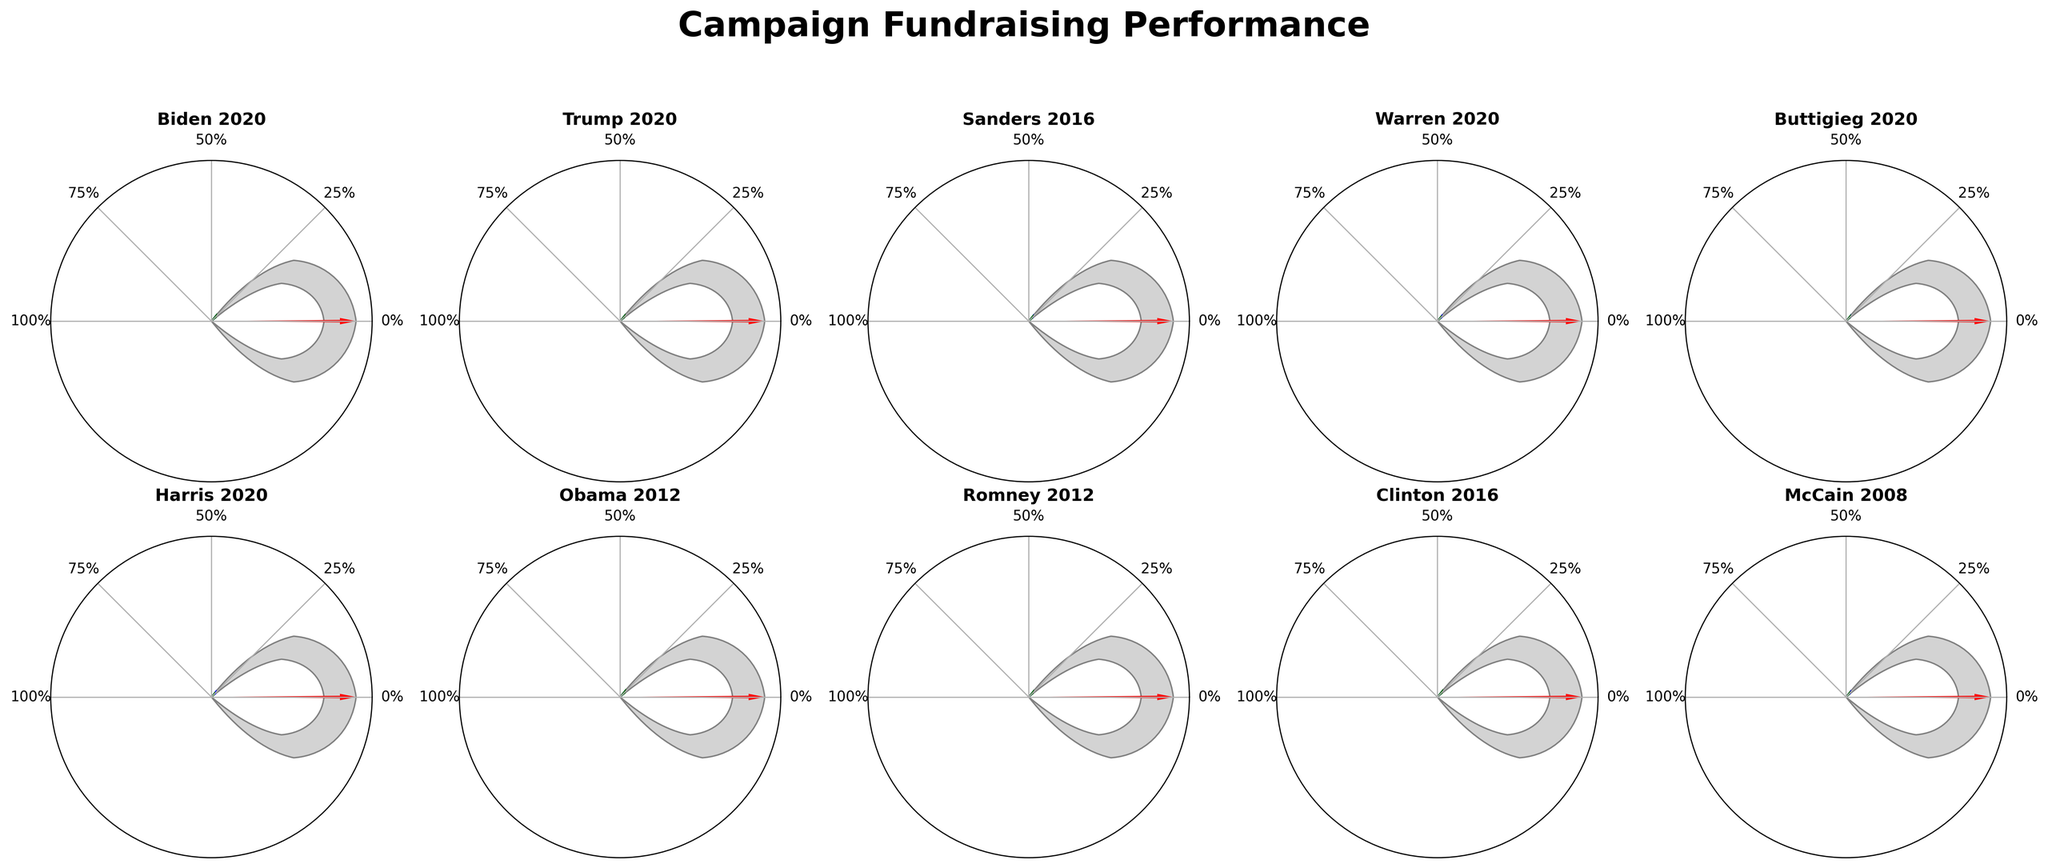How many campaigns surpassed their fundraising goal? From the rendering of the Gauge Charts, we observe the red needle as well as the green wedge. The needle indicates the actual amount raised, and when it exceeds the green wedge, this signifies that the goal was surpassed. The campaigns that surpassed their goals are Biden 2020, Obama 2012, and Clinton 2016.
Answer: 3 Which campaign had the largest difference between the raised amount and the goal? By looking at the gauge charts, we see that Obama 2012’s gauge extends furthest into the right, showing it surpassed its goal by 3%. This is the largest difference among all campaigns shown.
Answer: Obama 2012 Are there any campaigns that did not meet the industry benchmark? The industry benchmark is marked by a light blue wedge. Any campaign whose needle falls short of this wedge is below the industry benchmark. Analyzing the charts, Sanders 2016, Warren 2020, Buttigieg 2020, Harris 2020, and McCain 2008 did not meet the industry benchmark.
Answer: 5 campaigns What percentage of their goal did Trump 2020 raise? Referring to the needle in the Trump 2020 gauge chart, we see that it points to 92%.
Answer: 92% Which campaign raised the least amount relative to its goal? Analyzing the gauge charts, the Harris 2020 campaign shows the lowest amount, with the needle stopping at 57%.
Answer: Harris 2020 How many campaigns met the industry benchmark but did not surpass their goals? Campaigns meeting the benchmark but not surpassing their goal will have needles touching or surpassing the blue wedge but not extending beyond the 180-degree marker. Trump 2020, Sanders 2016, Buttigieg 2020, and Romney 2012 meet this condition.
Answer: 4 campaigns Was the raised amount from Clinton 2016 closer to the goal or the industry benchmark? The Clinton 2016 gauge chart shows a needle pointing just below the 100% mark, which is much closer to the goal (98%) and notably higher than the benchmark (85%).
Answer: Goal Which campaign's fundraising was exactly on target with its goal? No campaigns achieved exactly 100% on their gauge chart; several surpassed it slightly, and others fell short. Thus, none were on target.
Answer: None What is the average percentage of the goal achieved by all campaigns shown? Adding the percentages: (95 + 92 + 78 + 68 + 82 + 57 + 103 + 89 + 98 + 71) and calculating the average: (834 / 10)
Answer: 83.4% Which campaigns have raised more than the industry benchmark but did not exceed the goal? The campaigns that meet the industry benchmark threshold but stay below their goal have their needle between the blue wedge and the end of the green wedge. Valid campaigns are Trump 2020, Sanders 2016, Buttigieg 2020, and Romney 2012.
Answer: 4 campaigns 